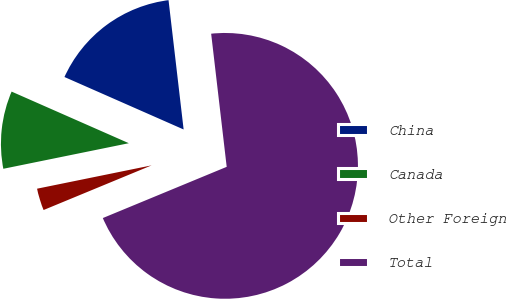Convert chart to OTSL. <chart><loc_0><loc_0><loc_500><loc_500><pie_chart><fcel>China<fcel>Canada<fcel>Other Foreign<fcel>Total<nl><fcel>16.55%<fcel>9.8%<fcel>3.04%<fcel>70.61%<nl></chart> 